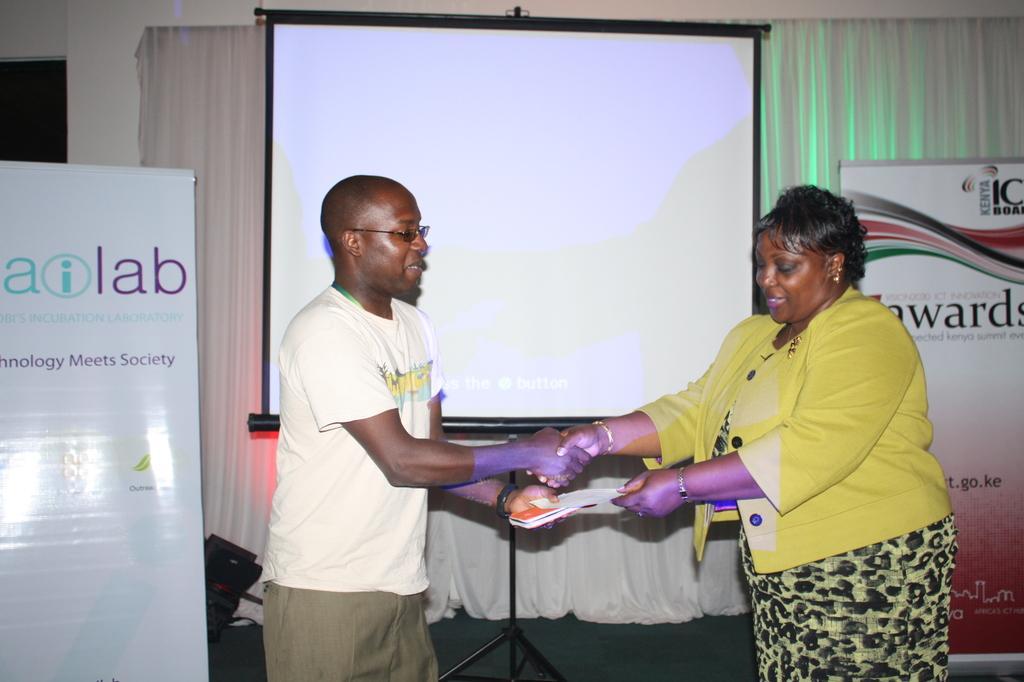How would you summarize this image in a sentence or two? Here we can see a man and a woman. They are smiling and holding a paper with their hands. There are banners and a board. In the background we can see a curtain and a wall. 